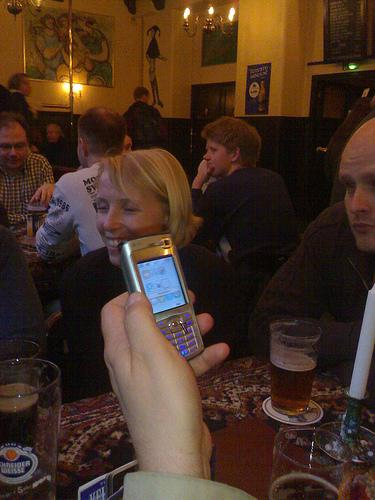Describe the centerpiece at the table. The centerpiece is a long, white unlit candle held in a candlestick holder, providing an elegant touch to the table setting at the restaurant. Discuss the role of coasters in the image. A coaster made of paper is placed under an empty pint glass, protecting the table from potential condensation and spills while keeping the table clean and organized. What emotions can be inferred from the image? The image has a cheerful atmosphere as the smiling blonde woman and other people seem to be enjoying themselves at the restaurant, having conversations and beverages. Point out the features of the cell phone in the image and describe how it is being held. The cell phone is small, silver, and lit up, and it is being held by a hand with a tan sleeve. The person is likely using the phone due to the lit-up screen. Describe the man wearing plaid in the image. The man wearing plaid has a small presence in the image, sitting at the edge of the table near the blonde woman, and possibly engaged in conversation with the rest of the group. Explain the appearance of the people in the image. There is a young blonde man, a woman with short blonde hair who is smiling, a man wearing plaid, and a man wearing a brown jacket with his left hand on his chin. They seem to be enjoying their time at the restaurant. Discuss the items related to beverages in the image. There is a pint glass of beer which is half full, an empty pint glass sitting on a paper coaster, and a beer advertisement featuring an image of a jester. It suggests that the restaurant may offer various types of beer. Describe the scene at the restaurant. The scene shows a group of people, including a smiling blonde woman and a man wearing a brown jacket with his left hand on his chin. They are sitting at a table with a pint glass of beer, white candles, and an empty glass sitting on a paper coaster. Identify the aspects of light sources in the image. There are hanging lights turned on, providing a warm glow to the restaurant. Additionally, the cell phone screen is lit up, suggesting that it is in use. How would you characterize the decorations in the image? There is a large rectangular picture, a beer advertisement featuring an image of a jester, a poster hanging on the wall, and hanging lights turned on, providing a cozy and lively atmosphere. 